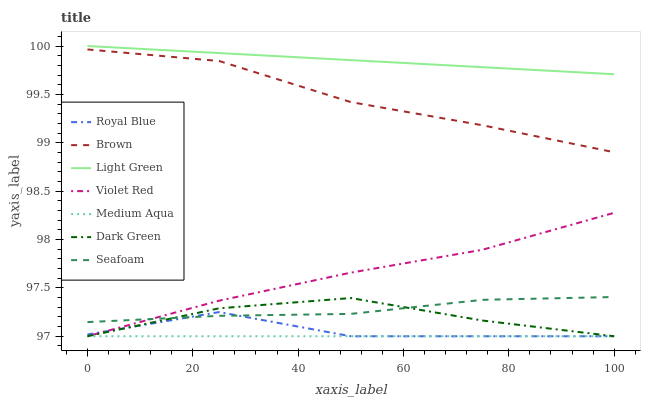Does Medium Aqua have the minimum area under the curve?
Answer yes or no. Yes. Does Light Green have the maximum area under the curve?
Answer yes or no. Yes. Does Violet Red have the minimum area under the curve?
Answer yes or no. No. Does Violet Red have the maximum area under the curve?
Answer yes or no. No. Is Medium Aqua the smoothest?
Answer yes or no. Yes. Is Royal Blue the roughest?
Answer yes or no. Yes. Is Violet Red the smoothest?
Answer yes or no. No. Is Violet Red the roughest?
Answer yes or no. No. Does Seafoam have the lowest value?
Answer yes or no. No. Does Violet Red have the highest value?
Answer yes or no. No. Is Dark Green less than Light Green?
Answer yes or no. Yes. Is Brown greater than Seafoam?
Answer yes or no. Yes. Does Dark Green intersect Light Green?
Answer yes or no. No. 